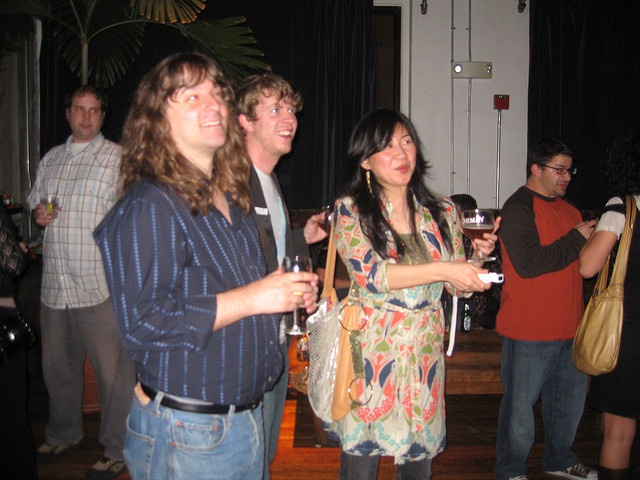Describe the objects in this image and their specific colors. I can see people in black, gray, and darkgray tones, people in black, tan, and darkgray tones, people in black, brown, and maroon tones, people in black, darkgray, and gray tones, and people in black, brown, and maroon tones in this image. 